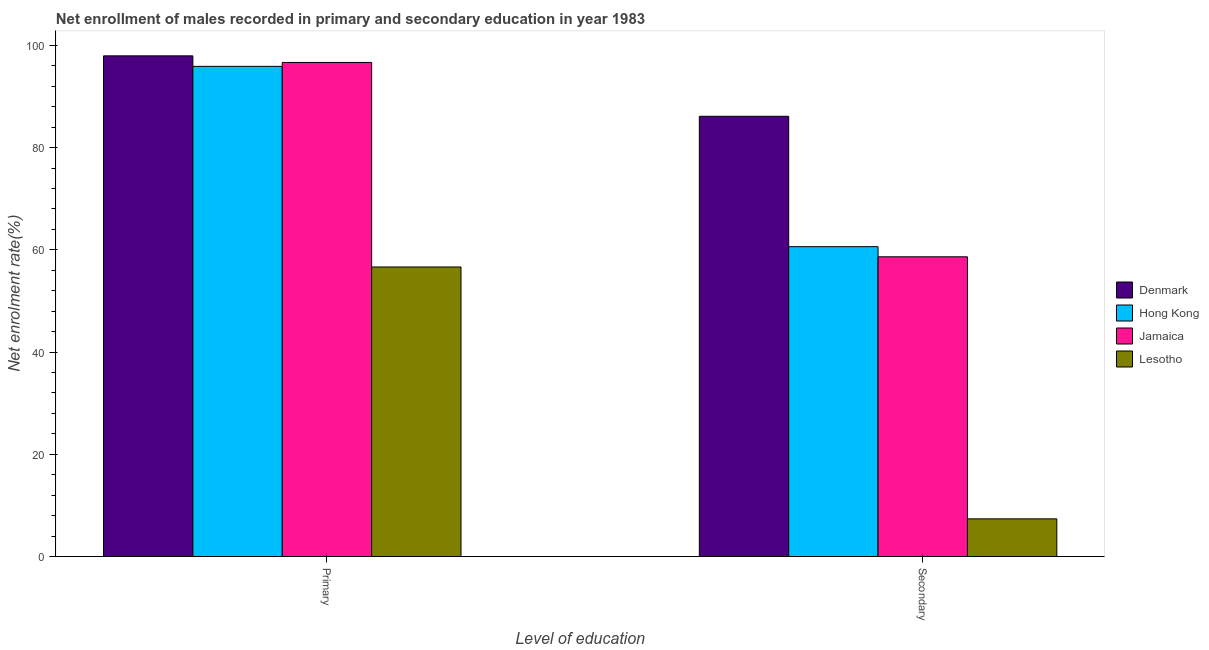How many groups of bars are there?
Keep it short and to the point. 2. Are the number of bars per tick equal to the number of legend labels?
Your answer should be compact. Yes. Are the number of bars on each tick of the X-axis equal?
Offer a terse response. Yes. How many bars are there on the 1st tick from the left?
Give a very brief answer. 4. What is the label of the 1st group of bars from the left?
Offer a very short reply. Primary. What is the enrollment rate in primary education in Hong Kong?
Provide a short and direct response. 95.88. Across all countries, what is the maximum enrollment rate in primary education?
Keep it short and to the point. 97.94. Across all countries, what is the minimum enrollment rate in primary education?
Give a very brief answer. 56.64. In which country was the enrollment rate in secondary education minimum?
Provide a short and direct response. Lesotho. What is the total enrollment rate in secondary education in the graph?
Offer a very short reply. 212.72. What is the difference between the enrollment rate in primary education in Hong Kong and that in Denmark?
Offer a very short reply. -2.06. What is the difference between the enrollment rate in secondary education in Hong Kong and the enrollment rate in primary education in Denmark?
Provide a succinct answer. -37.33. What is the average enrollment rate in primary education per country?
Give a very brief answer. 86.78. What is the difference between the enrollment rate in secondary education and enrollment rate in primary education in Jamaica?
Provide a succinct answer. -38.02. What is the ratio of the enrollment rate in secondary education in Lesotho to that in Hong Kong?
Keep it short and to the point. 0.12. Is the enrollment rate in primary education in Denmark less than that in Jamaica?
Provide a short and direct response. No. In how many countries, is the enrollment rate in secondary education greater than the average enrollment rate in secondary education taken over all countries?
Your answer should be very brief. 3. What does the 3rd bar from the left in Secondary represents?
Offer a very short reply. Jamaica. What does the 3rd bar from the right in Primary represents?
Your response must be concise. Hong Kong. Are all the bars in the graph horizontal?
Give a very brief answer. No. How many countries are there in the graph?
Ensure brevity in your answer.  4. Are the values on the major ticks of Y-axis written in scientific E-notation?
Your answer should be compact. No. Does the graph contain grids?
Your response must be concise. No. How are the legend labels stacked?
Provide a short and direct response. Vertical. What is the title of the graph?
Your answer should be compact. Net enrollment of males recorded in primary and secondary education in year 1983. What is the label or title of the X-axis?
Make the answer very short. Level of education. What is the label or title of the Y-axis?
Offer a very short reply. Net enrolment rate(%). What is the Net enrolment rate(%) of Denmark in Primary?
Your answer should be very brief. 97.94. What is the Net enrolment rate(%) of Hong Kong in Primary?
Provide a succinct answer. 95.88. What is the Net enrolment rate(%) in Jamaica in Primary?
Make the answer very short. 96.65. What is the Net enrolment rate(%) in Lesotho in Primary?
Ensure brevity in your answer.  56.64. What is the Net enrolment rate(%) of Denmark in Secondary?
Offer a very short reply. 86.11. What is the Net enrolment rate(%) in Hong Kong in Secondary?
Your answer should be compact. 60.61. What is the Net enrolment rate(%) of Jamaica in Secondary?
Your response must be concise. 58.63. What is the Net enrolment rate(%) in Lesotho in Secondary?
Offer a very short reply. 7.37. Across all Level of education, what is the maximum Net enrolment rate(%) of Denmark?
Keep it short and to the point. 97.94. Across all Level of education, what is the maximum Net enrolment rate(%) in Hong Kong?
Offer a terse response. 95.88. Across all Level of education, what is the maximum Net enrolment rate(%) of Jamaica?
Make the answer very short. 96.65. Across all Level of education, what is the maximum Net enrolment rate(%) in Lesotho?
Keep it short and to the point. 56.64. Across all Level of education, what is the minimum Net enrolment rate(%) in Denmark?
Your response must be concise. 86.11. Across all Level of education, what is the minimum Net enrolment rate(%) in Hong Kong?
Offer a terse response. 60.61. Across all Level of education, what is the minimum Net enrolment rate(%) in Jamaica?
Your response must be concise. 58.63. Across all Level of education, what is the minimum Net enrolment rate(%) in Lesotho?
Your response must be concise. 7.37. What is the total Net enrolment rate(%) of Denmark in the graph?
Offer a very short reply. 184.05. What is the total Net enrolment rate(%) of Hong Kong in the graph?
Make the answer very short. 156.49. What is the total Net enrolment rate(%) of Jamaica in the graph?
Your answer should be compact. 155.28. What is the total Net enrolment rate(%) in Lesotho in the graph?
Your answer should be compact. 64. What is the difference between the Net enrolment rate(%) of Denmark in Primary and that in Secondary?
Make the answer very short. 11.82. What is the difference between the Net enrolment rate(%) of Hong Kong in Primary and that in Secondary?
Your answer should be compact. 35.27. What is the difference between the Net enrolment rate(%) of Jamaica in Primary and that in Secondary?
Offer a very short reply. 38.02. What is the difference between the Net enrolment rate(%) in Lesotho in Primary and that in Secondary?
Provide a succinct answer. 49.27. What is the difference between the Net enrolment rate(%) of Denmark in Primary and the Net enrolment rate(%) of Hong Kong in Secondary?
Your answer should be very brief. 37.33. What is the difference between the Net enrolment rate(%) in Denmark in Primary and the Net enrolment rate(%) in Jamaica in Secondary?
Offer a very short reply. 39.31. What is the difference between the Net enrolment rate(%) in Denmark in Primary and the Net enrolment rate(%) in Lesotho in Secondary?
Provide a succinct answer. 90.57. What is the difference between the Net enrolment rate(%) of Hong Kong in Primary and the Net enrolment rate(%) of Jamaica in Secondary?
Give a very brief answer. 37.25. What is the difference between the Net enrolment rate(%) in Hong Kong in Primary and the Net enrolment rate(%) in Lesotho in Secondary?
Provide a succinct answer. 88.51. What is the difference between the Net enrolment rate(%) of Jamaica in Primary and the Net enrolment rate(%) of Lesotho in Secondary?
Offer a terse response. 89.28. What is the average Net enrolment rate(%) in Denmark per Level of education?
Offer a very short reply. 92.03. What is the average Net enrolment rate(%) in Hong Kong per Level of education?
Provide a succinct answer. 78.24. What is the average Net enrolment rate(%) in Jamaica per Level of education?
Keep it short and to the point. 77.64. What is the average Net enrolment rate(%) of Lesotho per Level of education?
Keep it short and to the point. 32. What is the difference between the Net enrolment rate(%) of Denmark and Net enrolment rate(%) of Hong Kong in Primary?
Your response must be concise. 2.06. What is the difference between the Net enrolment rate(%) of Denmark and Net enrolment rate(%) of Jamaica in Primary?
Make the answer very short. 1.29. What is the difference between the Net enrolment rate(%) of Denmark and Net enrolment rate(%) of Lesotho in Primary?
Your response must be concise. 41.3. What is the difference between the Net enrolment rate(%) of Hong Kong and Net enrolment rate(%) of Jamaica in Primary?
Keep it short and to the point. -0.77. What is the difference between the Net enrolment rate(%) of Hong Kong and Net enrolment rate(%) of Lesotho in Primary?
Your answer should be very brief. 39.24. What is the difference between the Net enrolment rate(%) of Jamaica and Net enrolment rate(%) of Lesotho in Primary?
Keep it short and to the point. 40.01. What is the difference between the Net enrolment rate(%) in Denmark and Net enrolment rate(%) in Hong Kong in Secondary?
Keep it short and to the point. 25.51. What is the difference between the Net enrolment rate(%) of Denmark and Net enrolment rate(%) of Jamaica in Secondary?
Give a very brief answer. 27.48. What is the difference between the Net enrolment rate(%) in Denmark and Net enrolment rate(%) in Lesotho in Secondary?
Keep it short and to the point. 78.75. What is the difference between the Net enrolment rate(%) in Hong Kong and Net enrolment rate(%) in Jamaica in Secondary?
Your answer should be compact. 1.98. What is the difference between the Net enrolment rate(%) in Hong Kong and Net enrolment rate(%) in Lesotho in Secondary?
Provide a succinct answer. 53.24. What is the difference between the Net enrolment rate(%) of Jamaica and Net enrolment rate(%) of Lesotho in Secondary?
Provide a succinct answer. 51.26. What is the ratio of the Net enrolment rate(%) of Denmark in Primary to that in Secondary?
Make the answer very short. 1.14. What is the ratio of the Net enrolment rate(%) in Hong Kong in Primary to that in Secondary?
Your answer should be very brief. 1.58. What is the ratio of the Net enrolment rate(%) in Jamaica in Primary to that in Secondary?
Your answer should be compact. 1.65. What is the ratio of the Net enrolment rate(%) in Lesotho in Primary to that in Secondary?
Give a very brief answer. 7.69. What is the difference between the highest and the second highest Net enrolment rate(%) in Denmark?
Give a very brief answer. 11.82. What is the difference between the highest and the second highest Net enrolment rate(%) in Hong Kong?
Provide a succinct answer. 35.27. What is the difference between the highest and the second highest Net enrolment rate(%) in Jamaica?
Provide a short and direct response. 38.02. What is the difference between the highest and the second highest Net enrolment rate(%) in Lesotho?
Keep it short and to the point. 49.27. What is the difference between the highest and the lowest Net enrolment rate(%) of Denmark?
Ensure brevity in your answer.  11.82. What is the difference between the highest and the lowest Net enrolment rate(%) of Hong Kong?
Ensure brevity in your answer.  35.27. What is the difference between the highest and the lowest Net enrolment rate(%) in Jamaica?
Offer a very short reply. 38.02. What is the difference between the highest and the lowest Net enrolment rate(%) in Lesotho?
Offer a very short reply. 49.27. 